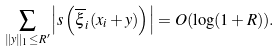Convert formula to latex. <formula><loc_0><loc_0><loc_500><loc_500>\sum _ { \| y \| _ { 1 } \leq R ^ { \prime } } \left | s \left ( \overline { \xi } _ { i } ( x _ { i } + y ) \right ) \right | = O ( \log ( 1 + R ) ) .</formula> 